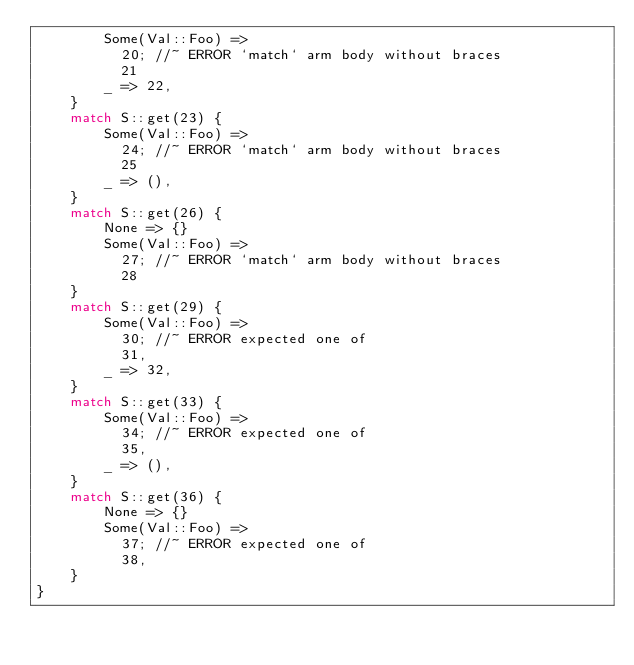Convert code to text. <code><loc_0><loc_0><loc_500><loc_500><_Rust_>        Some(Val::Foo) =>
          20; //~ ERROR `match` arm body without braces
          21
        _ => 22,
    }
    match S::get(23) {
        Some(Val::Foo) =>
          24; //~ ERROR `match` arm body without braces
          25
        _ => (),
    }
    match S::get(26) {
        None => {}
        Some(Val::Foo) =>
          27; //~ ERROR `match` arm body without braces
          28
    }
    match S::get(29) {
        Some(Val::Foo) =>
          30; //~ ERROR expected one of
          31,
        _ => 32,
    }
    match S::get(33) {
        Some(Val::Foo) =>
          34; //~ ERROR expected one of
          35,
        _ => (),
    }
    match S::get(36) {
        None => {}
        Some(Val::Foo) =>
          37; //~ ERROR expected one of
          38,
    }
}
</code> 